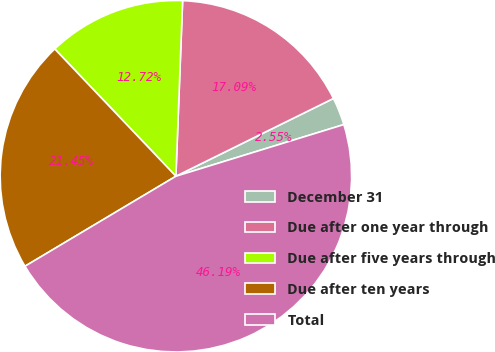Convert chart. <chart><loc_0><loc_0><loc_500><loc_500><pie_chart><fcel>December 31<fcel>Due after one year through<fcel>Due after five years through<fcel>Due after ten years<fcel>Total<nl><fcel>2.55%<fcel>17.09%<fcel>12.72%<fcel>21.45%<fcel>46.19%<nl></chart> 